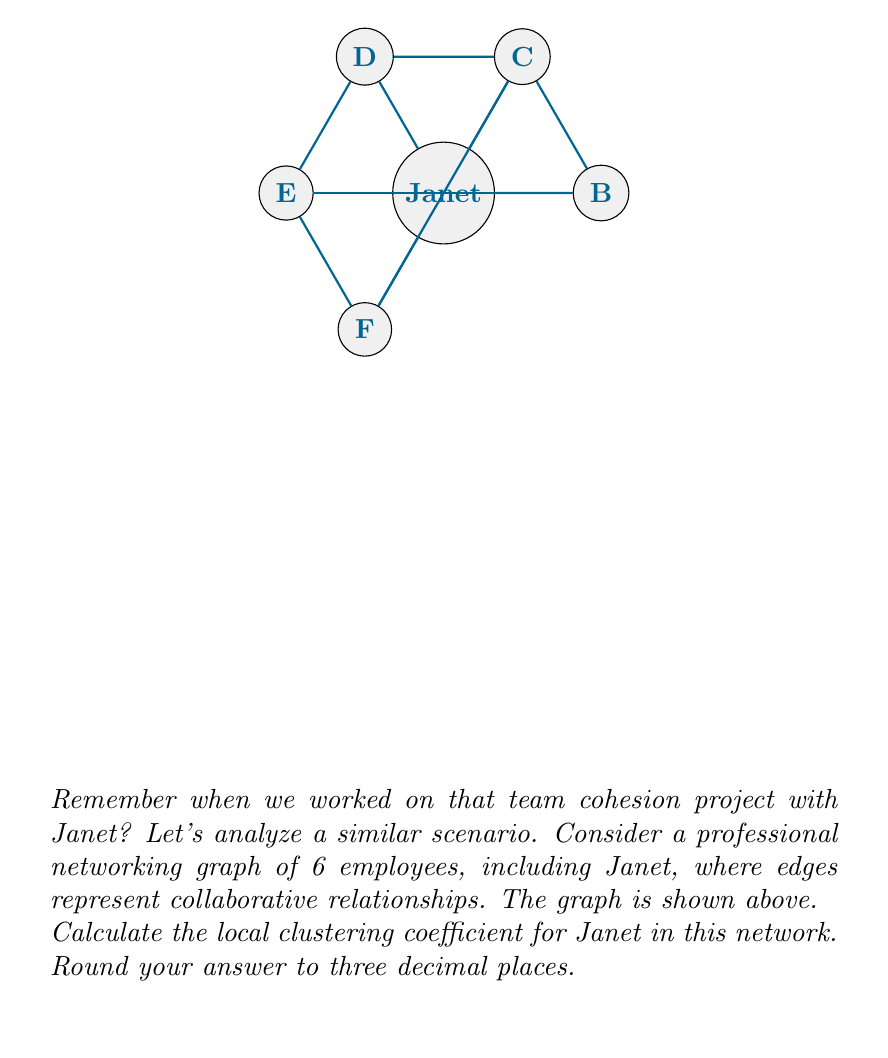Can you answer this question? Let's approach this step-by-step:

1) The local clustering coefficient $C_i$ for a vertex $i$ is given by the formula:

   $$C_i = \frac{2 \cdot e_i}{k_i(k_i-1)}$$

   where $e_i$ is the number of edges between the neighbors of vertex $i$, and $k_i$ is the degree of vertex $i$.

2) For Janet (vertex A):
   - Her degree $k_i$ is 4 (she's connected to B, C, D, and F).
   - Among Janet's neighbors:
     * B is connected to C
     * C is connected to D and F
     * D is connected to F
   - So, the number of edges between Janet's neighbors $e_i$ is 4.

3) Plugging these values into the formula:

   $$C_{\text{Janet}} = \frac{2 \cdot 4}{4(4-1)} = \frac{8}{12} = \frac{2}{3} \approx 0.667$$

4) Rounding to three decimal places: 0.667

This clustering coefficient indicates a relatively high level of interconnectedness among Janet's immediate collaborators, suggesting strong team cohesion in her local network.
Answer: 0.667 